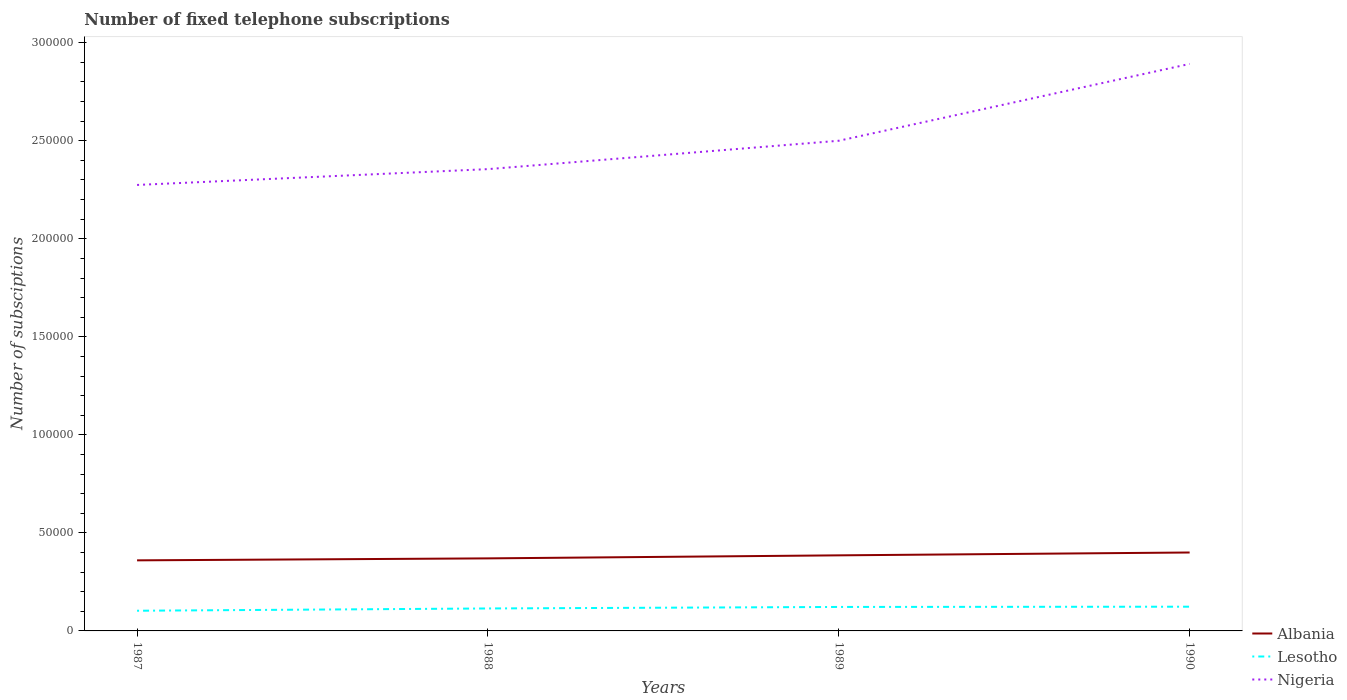How many different coloured lines are there?
Provide a succinct answer. 3. Does the line corresponding to Nigeria intersect with the line corresponding to Lesotho?
Your answer should be very brief. No. Is the number of lines equal to the number of legend labels?
Ensure brevity in your answer.  Yes. Across all years, what is the maximum number of fixed telephone subscriptions in Albania?
Offer a terse response. 3.60e+04. In which year was the number of fixed telephone subscriptions in Albania maximum?
Your answer should be very brief. 1987. What is the total number of fixed telephone subscriptions in Albania in the graph?
Provide a succinct answer. -1450. What is the difference between the highest and the second highest number of fixed telephone subscriptions in Nigeria?
Keep it short and to the point. 6.17e+04. How many lines are there?
Provide a short and direct response. 3. How many years are there in the graph?
Offer a very short reply. 4. What is the difference between two consecutive major ticks on the Y-axis?
Your answer should be compact. 5.00e+04. Does the graph contain any zero values?
Your answer should be very brief. No. How many legend labels are there?
Offer a terse response. 3. How are the legend labels stacked?
Your response must be concise. Vertical. What is the title of the graph?
Provide a succinct answer. Number of fixed telephone subscriptions. Does "Indonesia" appear as one of the legend labels in the graph?
Your answer should be compact. No. What is the label or title of the X-axis?
Give a very brief answer. Years. What is the label or title of the Y-axis?
Make the answer very short. Number of subsciptions. What is the Number of subsciptions of Albania in 1987?
Provide a short and direct response. 3.60e+04. What is the Number of subsciptions in Lesotho in 1987?
Offer a very short reply. 1.03e+04. What is the Number of subsciptions in Nigeria in 1987?
Your answer should be compact. 2.27e+05. What is the Number of subsciptions of Albania in 1988?
Provide a succinct answer. 3.70e+04. What is the Number of subsciptions in Lesotho in 1988?
Make the answer very short. 1.15e+04. What is the Number of subsciptions in Nigeria in 1988?
Provide a succinct answer. 2.36e+05. What is the Number of subsciptions in Albania in 1989?
Provide a short and direct response. 3.86e+04. What is the Number of subsciptions of Lesotho in 1989?
Give a very brief answer. 1.22e+04. What is the Number of subsciptions in Lesotho in 1990?
Make the answer very short. 1.24e+04. What is the Number of subsciptions of Nigeria in 1990?
Offer a terse response. 2.89e+05. Across all years, what is the maximum Number of subsciptions of Lesotho?
Give a very brief answer. 1.24e+04. Across all years, what is the maximum Number of subsciptions in Nigeria?
Offer a terse response. 2.89e+05. Across all years, what is the minimum Number of subsciptions in Albania?
Your response must be concise. 3.60e+04. Across all years, what is the minimum Number of subsciptions in Lesotho?
Provide a short and direct response. 1.03e+04. Across all years, what is the minimum Number of subsciptions in Nigeria?
Offer a terse response. 2.27e+05. What is the total Number of subsciptions of Albania in the graph?
Offer a very short reply. 1.52e+05. What is the total Number of subsciptions in Lesotho in the graph?
Offer a terse response. 4.63e+04. What is the total Number of subsciptions in Nigeria in the graph?
Make the answer very short. 1.00e+06. What is the difference between the Number of subsciptions in Albania in 1987 and that in 1988?
Give a very brief answer. -1000. What is the difference between the Number of subsciptions of Lesotho in 1987 and that in 1988?
Keep it short and to the point. -1161. What is the difference between the Number of subsciptions of Nigeria in 1987 and that in 1988?
Ensure brevity in your answer.  -8070. What is the difference between the Number of subsciptions in Albania in 1987 and that in 1989?
Make the answer very short. -2550. What is the difference between the Number of subsciptions of Lesotho in 1987 and that in 1989?
Provide a short and direct response. -1933. What is the difference between the Number of subsciptions of Nigeria in 1987 and that in 1989?
Make the answer very short. -2.25e+04. What is the difference between the Number of subsciptions of Albania in 1987 and that in 1990?
Offer a very short reply. -4000. What is the difference between the Number of subsciptions in Lesotho in 1987 and that in 1990?
Offer a terse response. -2062. What is the difference between the Number of subsciptions in Nigeria in 1987 and that in 1990?
Your response must be concise. -6.17e+04. What is the difference between the Number of subsciptions in Albania in 1988 and that in 1989?
Offer a terse response. -1550. What is the difference between the Number of subsciptions in Lesotho in 1988 and that in 1989?
Offer a terse response. -772. What is the difference between the Number of subsciptions of Nigeria in 1988 and that in 1989?
Give a very brief answer. -1.45e+04. What is the difference between the Number of subsciptions of Albania in 1988 and that in 1990?
Ensure brevity in your answer.  -3000. What is the difference between the Number of subsciptions of Lesotho in 1988 and that in 1990?
Offer a terse response. -901. What is the difference between the Number of subsciptions of Nigeria in 1988 and that in 1990?
Give a very brief answer. -5.37e+04. What is the difference between the Number of subsciptions of Albania in 1989 and that in 1990?
Provide a succinct answer. -1450. What is the difference between the Number of subsciptions in Lesotho in 1989 and that in 1990?
Your response must be concise. -129. What is the difference between the Number of subsciptions of Nigeria in 1989 and that in 1990?
Provide a succinct answer. -3.92e+04. What is the difference between the Number of subsciptions of Albania in 1987 and the Number of subsciptions of Lesotho in 1988?
Provide a succinct answer. 2.45e+04. What is the difference between the Number of subsciptions in Albania in 1987 and the Number of subsciptions in Nigeria in 1988?
Offer a very short reply. -2.00e+05. What is the difference between the Number of subsciptions of Lesotho in 1987 and the Number of subsciptions of Nigeria in 1988?
Your answer should be compact. -2.25e+05. What is the difference between the Number of subsciptions in Albania in 1987 and the Number of subsciptions in Lesotho in 1989?
Offer a terse response. 2.38e+04. What is the difference between the Number of subsciptions in Albania in 1987 and the Number of subsciptions in Nigeria in 1989?
Provide a short and direct response. -2.14e+05. What is the difference between the Number of subsciptions of Lesotho in 1987 and the Number of subsciptions of Nigeria in 1989?
Provide a short and direct response. -2.40e+05. What is the difference between the Number of subsciptions in Albania in 1987 and the Number of subsciptions in Lesotho in 1990?
Your answer should be compact. 2.36e+04. What is the difference between the Number of subsciptions of Albania in 1987 and the Number of subsciptions of Nigeria in 1990?
Your response must be concise. -2.53e+05. What is the difference between the Number of subsciptions in Lesotho in 1987 and the Number of subsciptions in Nigeria in 1990?
Your answer should be very brief. -2.79e+05. What is the difference between the Number of subsciptions of Albania in 1988 and the Number of subsciptions of Lesotho in 1989?
Make the answer very short. 2.48e+04. What is the difference between the Number of subsciptions of Albania in 1988 and the Number of subsciptions of Nigeria in 1989?
Make the answer very short. -2.13e+05. What is the difference between the Number of subsciptions of Lesotho in 1988 and the Number of subsciptions of Nigeria in 1989?
Make the answer very short. -2.39e+05. What is the difference between the Number of subsciptions in Albania in 1988 and the Number of subsciptions in Lesotho in 1990?
Offer a terse response. 2.46e+04. What is the difference between the Number of subsciptions in Albania in 1988 and the Number of subsciptions in Nigeria in 1990?
Your answer should be compact. -2.52e+05. What is the difference between the Number of subsciptions of Lesotho in 1988 and the Number of subsciptions of Nigeria in 1990?
Your answer should be compact. -2.78e+05. What is the difference between the Number of subsciptions in Albania in 1989 and the Number of subsciptions in Lesotho in 1990?
Your response must be concise. 2.62e+04. What is the difference between the Number of subsciptions of Albania in 1989 and the Number of subsciptions of Nigeria in 1990?
Ensure brevity in your answer.  -2.51e+05. What is the difference between the Number of subsciptions of Lesotho in 1989 and the Number of subsciptions of Nigeria in 1990?
Offer a very short reply. -2.77e+05. What is the average Number of subsciptions of Albania per year?
Offer a very short reply. 3.79e+04. What is the average Number of subsciptions of Lesotho per year?
Give a very brief answer. 1.16e+04. What is the average Number of subsciptions in Nigeria per year?
Your answer should be compact. 2.51e+05. In the year 1987, what is the difference between the Number of subsciptions in Albania and Number of subsciptions in Lesotho?
Offer a terse response. 2.57e+04. In the year 1987, what is the difference between the Number of subsciptions of Albania and Number of subsciptions of Nigeria?
Give a very brief answer. -1.91e+05. In the year 1987, what is the difference between the Number of subsciptions in Lesotho and Number of subsciptions in Nigeria?
Provide a succinct answer. -2.17e+05. In the year 1988, what is the difference between the Number of subsciptions in Albania and Number of subsciptions in Lesotho?
Keep it short and to the point. 2.55e+04. In the year 1988, what is the difference between the Number of subsciptions in Albania and Number of subsciptions in Nigeria?
Provide a succinct answer. -1.99e+05. In the year 1988, what is the difference between the Number of subsciptions in Lesotho and Number of subsciptions in Nigeria?
Provide a succinct answer. -2.24e+05. In the year 1989, what is the difference between the Number of subsciptions of Albania and Number of subsciptions of Lesotho?
Provide a short and direct response. 2.63e+04. In the year 1989, what is the difference between the Number of subsciptions in Albania and Number of subsciptions in Nigeria?
Your response must be concise. -2.11e+05. In the year 1989, what is the difference between the Number of subsciptions of Lesotho and Number of subsciptions of Nigeria?
Offer a terse response. -2.38e+05. In the year 1990, what is the difference between the Number of subsciptions in Albania and Number of subsciptions in Lesotho?
Offer a very short reply. 2.76e+04. In the year 1990, what is the difference between the Number of subsciptions in Albania and Number of subsciptions in Nigeria?
Make the answer very short. -2.49e+05. In the year 1990, what is the difference between the Number of subsciptions in Lesotho and Number of subsciptions in Nigeria?
Your answer should be compact. -2.77e+05. What is the ratio of the Number of subsciptions in Albania in 1987 to that in 1988?
Your answer should be compact. 0.97. What is the ratio of the Number of subsciptions in Lesotho in 1987 to that in 1988?
Keep it short and to the point. 0.9. What is the ratio of the Number of subsciptions of Nigeria in 1987 to that in 1988?
Offer a terse response. 0.97. What is the ratio of the Number of subsciptions of Albania in 1987 to that in 1989?
Offer a very short reply. 0.93. What is the ratio of the Number of subsciptions of Lesotho in 1987 to that in 1989?
Give a very brief answer. 0.84. What is the ratio of the Number of subsciptions in Nigeria in 1987 to that in 1989?
Your answer should be very brief. 0.91. What is the ratio of the Number of subsciptions of Albania in 1987 to that in 1990?
Ensure brevity in your answer.  0.9. What is the ratio of the Number of subsciptions in Lesotho in 1987 to that in 1990?
Make the answer very short. 0.83. What is the ratio of the Number of subsciptions of Nigeria in 1987 to that in 1990?
Your answer should be very brief. 0.79. What is the ratio of the Number of subsciptions in Albania in 1988 to that in 1989?
Ensure brevity in your answer.  0.96. What is the ratio of the Number of subsciptions of Lesotho in 1988 to that in 1989?
Provide a short and direct response. 0.94. What is the ratio of the Number of subsciptions in Nigeria in 1988 to that in 1989?
Your response must be concise. 0.94. What is the ratio of the Number of subsciptions of Albania in 1988 to that in 1990?
Your answer should be very brief. 0.93. What is the ratio of the Number of subsciptions of Lesotho in 1988 to that in 1990?
Give a very brief answer. 0.93. What is the ratio of the Number of subsciptions of Nigeria in 1988 to that in 1990?
Offer a terse response. 0.81. What is the ratio of the Number of subsciptions of Albania in 1989 to that in 1990?
Your answer should be compact. 0.96. What is the ratio of the Number of subsciptions in Nigeria in 1989 to that in 1990?
Keep it short and to the point. 0.86. What is the difference between the highest and the second highest Number of subsciptions of Albania?
Make the answer very short. 1450. What is the difference between the highest and the second highest Number of subsciptions of Lesotho?
Your response must be concise. 129. What is the difference between the highest and the second highest Number of subsciptions in Nigeria?
Provide a succinct answer. 3.92e+04. What is the difference between the highest and the lowest Number of subsciptions of Albania?
Provide a short and direct response. 4000. What is the difference between the highest and the lowest Number of subsciptions in Lesotho?
Ensure brevity in your answer.  2062. What is the difference between the highest and the lowest Number of subsciptions of Nigeria?
Give a very brief answer. 6.17e+04. 